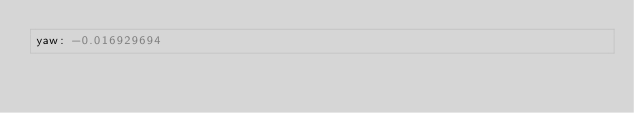<code> <loc_0><loc_0><loc_500><loc_500><_YAML_>yaw: -0.016929694
</code> 